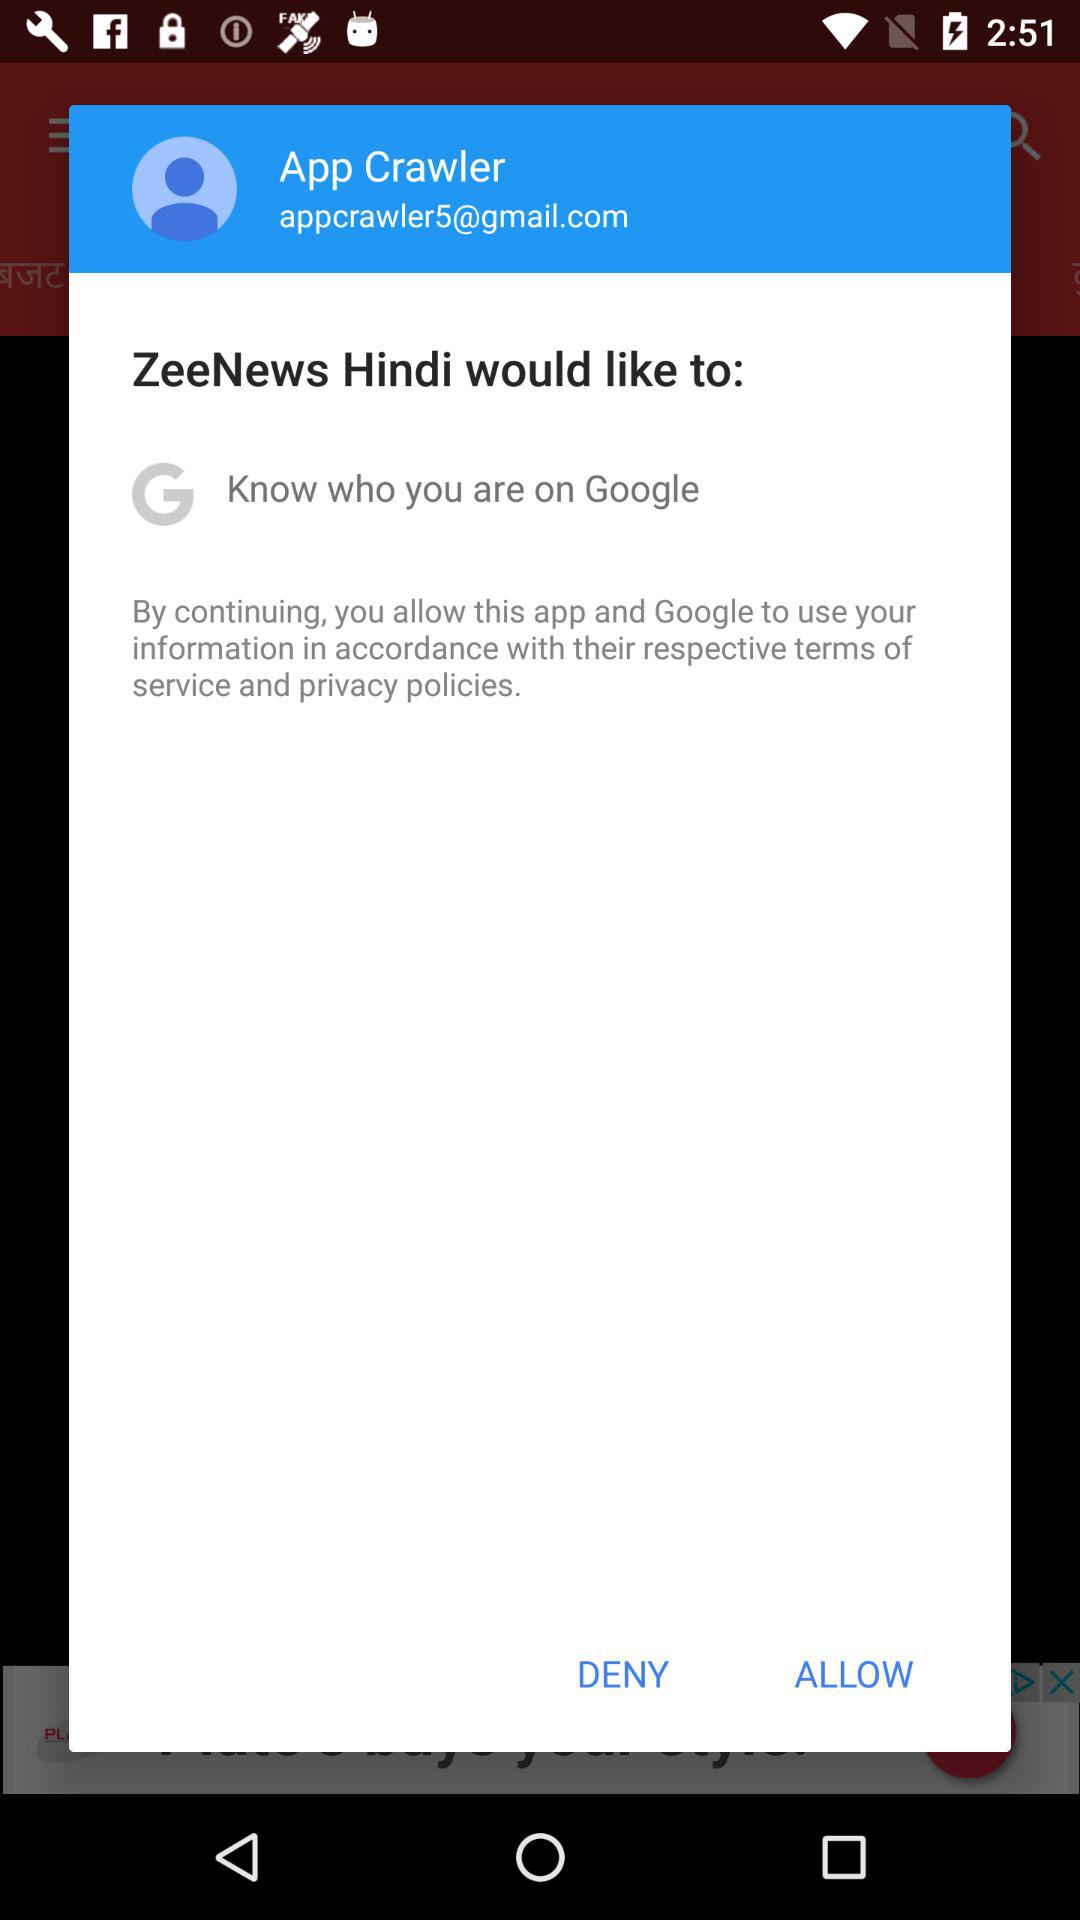What is the name of the user? The name of the user is App Crawler. 